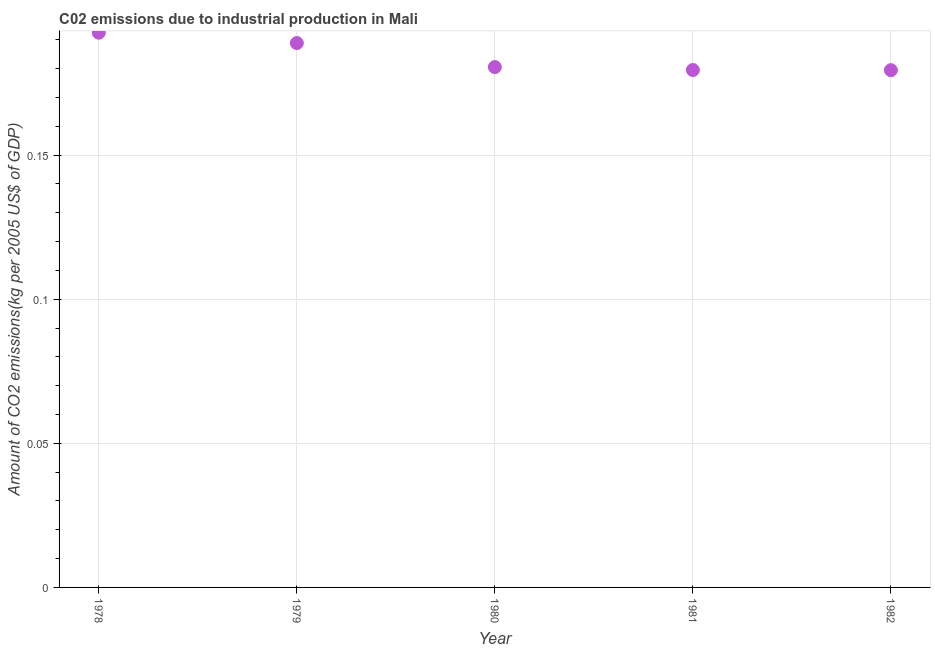What is the amount of co2 emissions in 1978?
Offer a terse response. 0.19. Across all years, what is the maximum amount of co2 emissions?
Keep it short and to the point. 0.19. Across all years, what is the minimum amount of co2 emissions?
Your response must be concise. 0.18. In which year was the amount of co2 emissions maximum?
Ensure brevity in your answer.  1978. What is the sum of the amount of co2 emissions?
Your response must be concise. 0.92. What is the difference between the amount of co2 emissions in 1979 and 1980?
Keep it short and to the point. 0.01. What is the average amount of co2 emissions per year?
Make the answer very short. 0.18. What is the median amount of co2 emissions?
Offer a terse response. 0.18. What is the ratio of the amount of co2 emissions in 1978 to that in 1979?
Give a very brief answer. 1.02. Is the amount of co2 emissions in 1980 less than that in 1982?
Provide a succinct answer. No. Is the difference between the amount of co2 emissions in 1979 and 1981 greater than the difference between any two years?
Keep it short and to the point. No. What is the difference between the highest and the second highest amount of co2 emissions?
Keep it short and to the point. 0. What is the difference between the highest and the lowest amount of co2 emissions?
Keep it short and to the point. 0.01. In how many years, is the amount of co2 emissions greater than the average amount of co2 emissions taken over all years?
Keep it short and to the point. 2. How many years are there in the graph?
Provide a short and direct response. 5. What is the difference between two consecutive major ticks on the Y-axis?
Offer a terse response. 0.05. Does the graph contain grids?
Offer a terse response. Yes. What is the title of the graph?
Keep it short and to the point. C02 emissions due to industrial production in Mali. What is the label or title of the Y-axis?
Provide a short and direct response. Amount of CO2 emissions(kg per 2005 US$ of GDP). What is the Amount of CO2 emissions(kg per 2005 US$ of GDP) in 1978?
Provide a short and direct response. 0.19. What is the Amount of CO2 emissions(kg per 2005 US$ of GDP) in 1979?
Provide a succinct answer. 0.19. What is the Amount of CO2 emissions(kg per 2005 US$ of GDP) in 1980?
Your answer should be very brief. 0.18. What is the Amount of CO2 emissions(kg per 2005 US$ of GDP) in 1981?
Ensure brevity in your answer.  0.18. What is the Amount of CO2 emissions(kg per 2005 US$ of GDP) in 1982?
Make the answer very short. 0.18. What is the difference between the Amount of CO2 emissions(kg per 2005 US$ of GDP) in 1978 and 1979?
Your answer should be very brief. 0. What is the difference between the Amount of CO2 emissions(kg per 2005 US$ of GDP) in 1978 and 1980?
Make the answer very short. 0.01. What is the difference between the Amount of CO2 emissions(kg per 2005 US$ of GDP) in 1978 and 1981?
Your answer should be very brief. 0.01. What is the difference between the Amount of CO2 emissions(kg per 2005 US$ of GDP) in 1978 and 1982?
Your answer should be very brief. 0.01. What is the difference between the Amount of CO2 emissions(kg per 2005 US$ of GDP) in 1979 and 1980?
Ensure brevity in your answer.  0.01. What is the difference between the Amount of CO2 emissions(kg per 2005 US$ of GDP) in 1979 and 1981?
Your response must be concise. 0.01. What is the difference between the Amount of CO2 emissions(kg per 2005 US$ of GDP) in 1979 and 1982?
Provide a succinct answer. 0.01. What is the difference between the Amount of CO2 emissions(kg per 2005 US$ of GDP) in 1980 and 1981?
Make the answer very short. 0. What is the difference between the Amount of CO2 emissions(kg per 2005 US$ of GDP) in 1980 and 1982?
Offer a very short reply. 0. What is the difference between the Amount of CO2 emissions(kg per 2005 US$ of GDP) in 1981 and 1982?
Make the answer very short. 6e-5. What is the ratio of the Amount of CO2 emissions(kg per 2005 US$ of GDP) in 1978 to that in 1980?
Your answer should be compact. 1.07. What is the ratio of the Amount of CO2 emissions(kg per 2005 US$ of GDP) in 1978 to that in 1981?
Offer a terse response. 1.07. What is the ratio of the Amount of CO2 emissions(kg per 2005 US$ of GDP) in 1978 to that in 1982?
Make the answer very short. 1.07. What is the ratio of the Amount of CO2 emissions(kg per 2005 US$ of GDP) in 1979 to that in 1980?
Provide a short and direct response. 1.05. What is the ratio of the Amount of CO2 emissions(kg per 2005 US$ of GDP) in 1979 to that in 1981?
Offer a terse response. 1.05. What is the ratio of the Amount of CO2 emissions(kg per 2005 US$ of GDP) in 1979 to that in 1982?
Provide a short and direct response. 1.05. What is the ratio of the Amount of CO2 emissions(kg per 2005 US$ of GDP) in 1980 to that in 1982?
Provide a short and direct response. 1.01. 